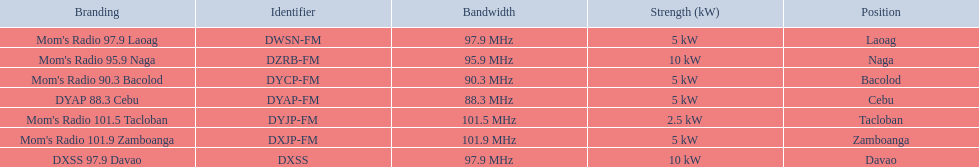How many times is the frequency greater than 95? 5. 